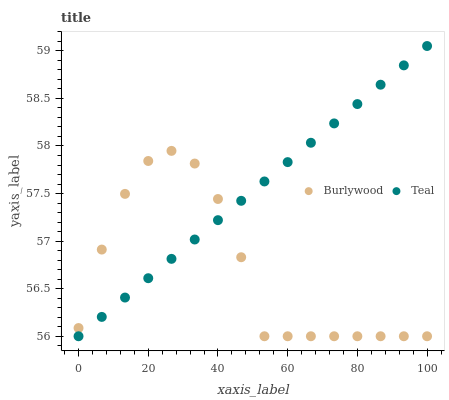Does Burlywood have the minimum area under the curve?
Answer yes or no. Yes. Does Teal have the maximum area under the curve?
Answer yes or no. Yes. Does Teal have the minimum area under the curve?
Answer yes or no. No. Is Teal the smoothest?
Answer yes or no. Yes. Is Burlywood the roughest?
Answer yes or no. Yes. Is Teal the roughest?
Answer yes or no. No. Does Burlywood have the lowest value?
Answer yes or no. Yes. Does Teal have the highest value?
Answer yes or no. Yes. Does Teal intersect Burlywood?
Answer yes or no. Yes. Is Teal less than Burlywood?
Answer yes or no. No. Is Teal greater than Burlywood?
Answer yes or no. No. 